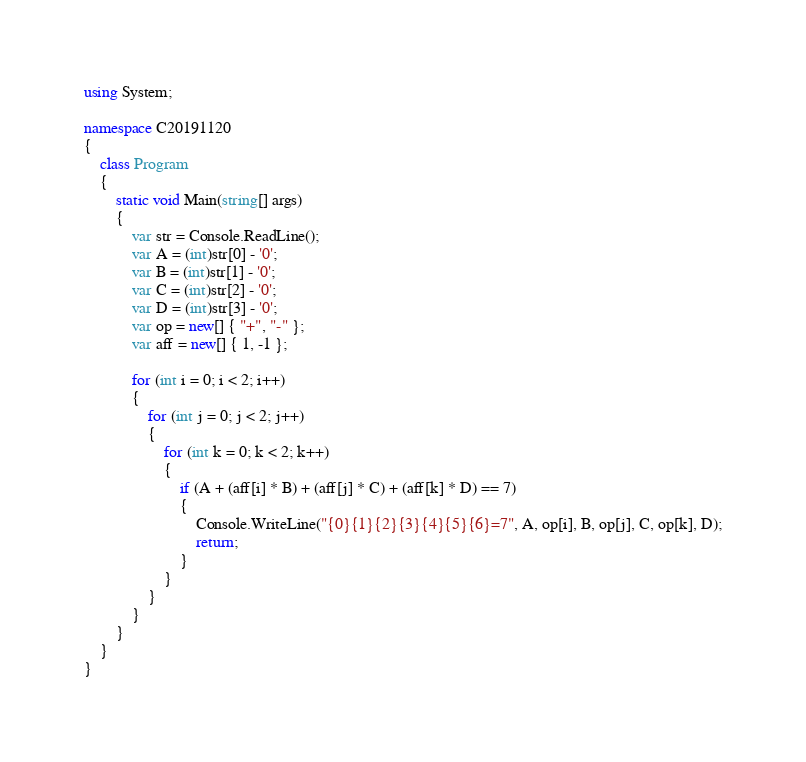Convert code to text. <code><loc_0><loc_0><loc_500><loc_500><_C#_>using System;

namespace C20191120
{
    class Program
    {
        static void Main(string[] args)
        {
            var str = Console.ReadLine();
            var A = (int)str[0] - '0';
            var B = (int)str[1] - '0';
            var C = (int)str[2] - '0';
            var D = (int)str[3] - '0';
            var op = new[] { "+", "-" };
            var aff = new[] { 1, -1 };

            for (int i = 0; i < 2; i++)
            {
                for (int j = 0; j < 2; j++)
                {
                    for (int k = 0; k < 2; k++)
                    {
                        if (A + (aff[i] * B) + (aff[j] * C) + (aff[k] * D) == 7)
                        {
                            Console.WriteLine("{0}{1}{2}{3}{4}{5}{6}=7", A, op[i], B, op[j], C, op[k], D);
                            return;
                        }
                    }
                }
            }
        }
    }
}</code> 